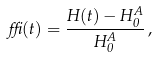Convert formula to latex. <formula><loc_0><loc_0><loc_500><loc_500>\delta ( t ) = \frac { H ( t ) - H _ { 0 } ^ { A } } { H _ { 0 } ^ { A } } \, ,</formula> 